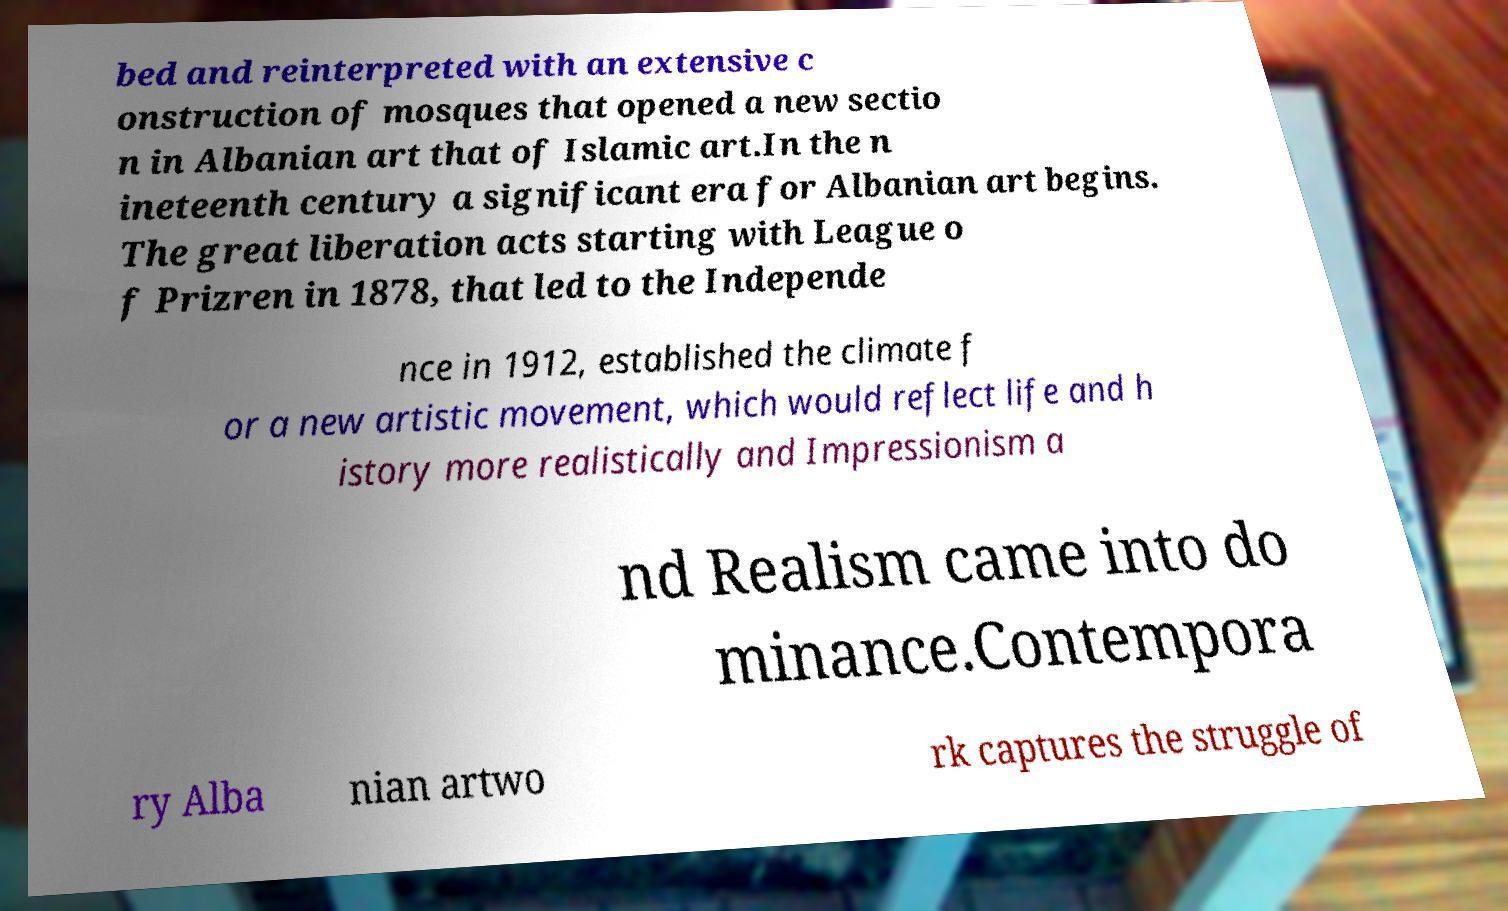Could you extract and type out the text from this image? bed and reinterpreted with an extensive c onstruction of mosques that opened a new sectio n in Albanian art that of Islamic art.In the n ineteenth century a significant era for Albanian art begins. The great liberation acts starting with League o f Prizren in 1878, that led to the Independe nce in 1912, established the climate f or a new artistic movement, which would reflect life and h istory more realistically and Impressionism a nd Realism came into do minance.Contempora ry Alba nian artwo rk captures the struggle of 